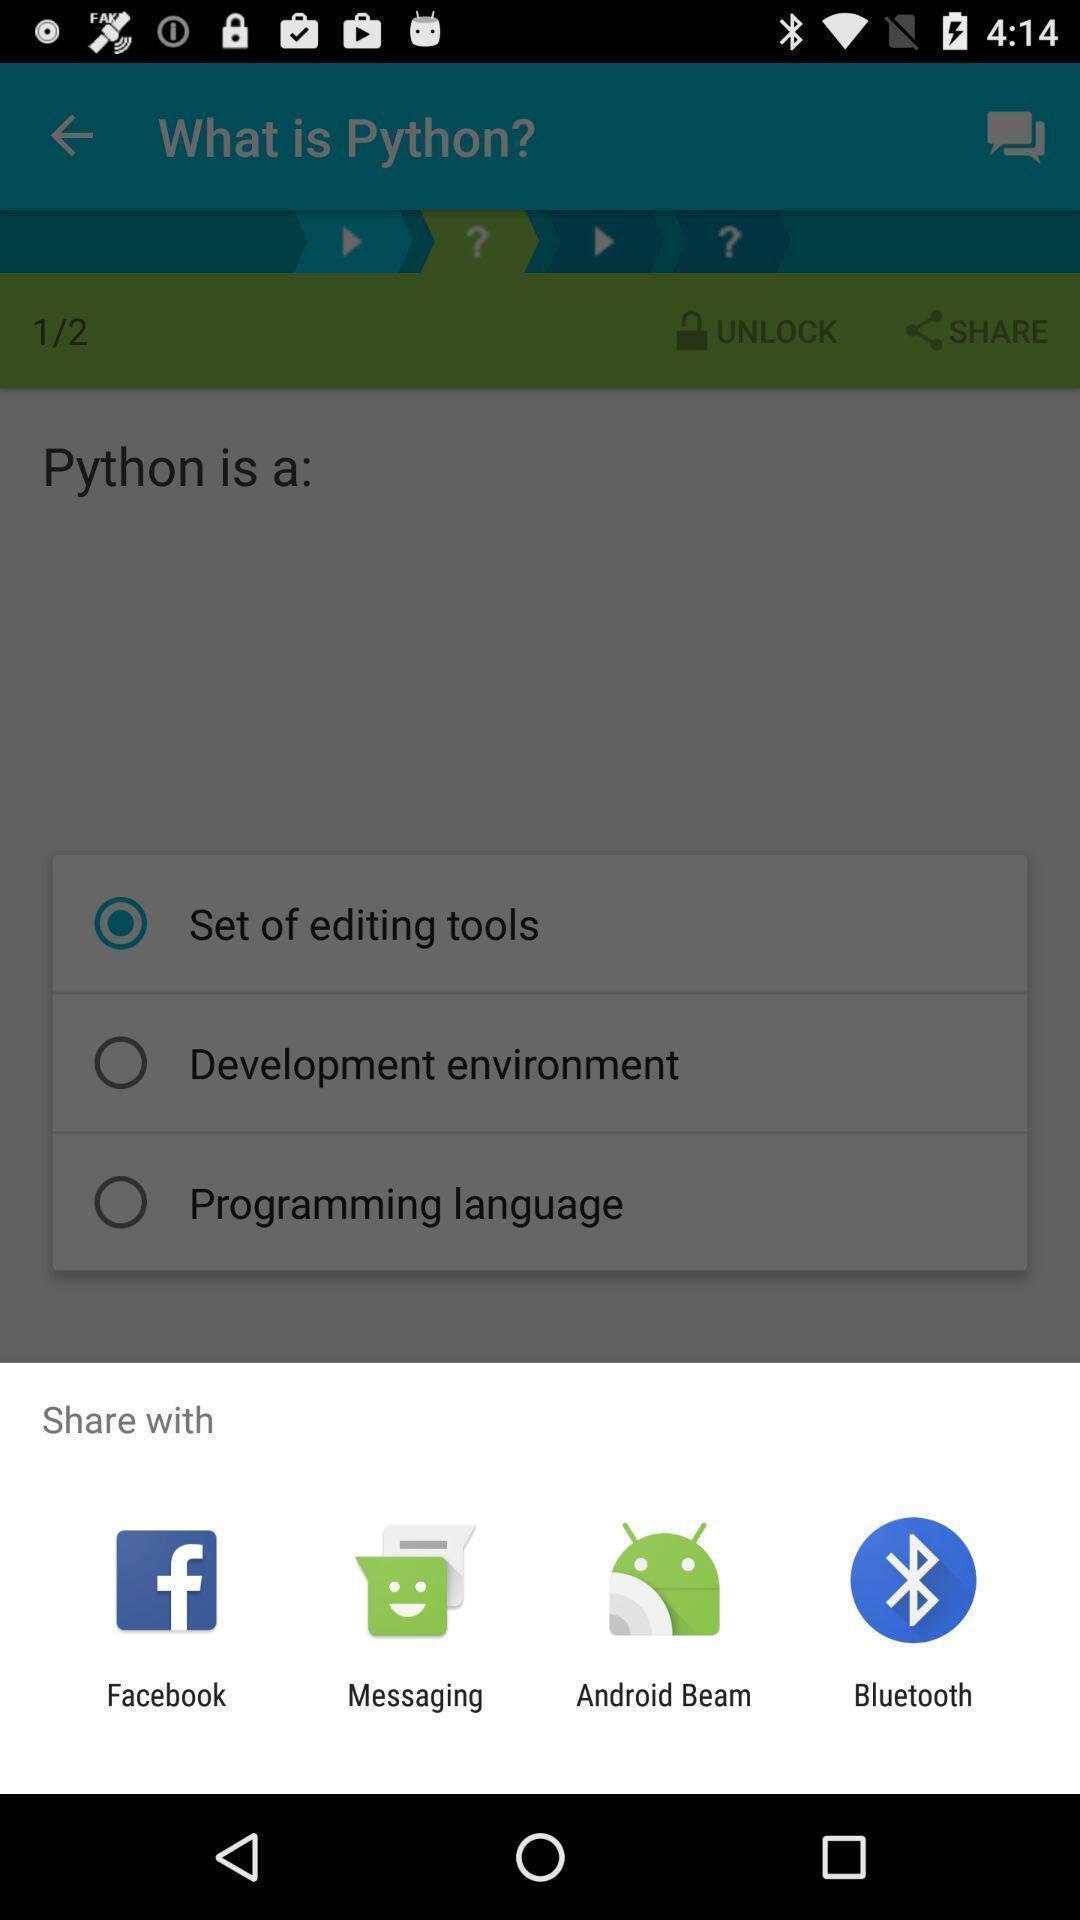Give me a summary of this screen capture. Widget displaying different data sharing apps. 